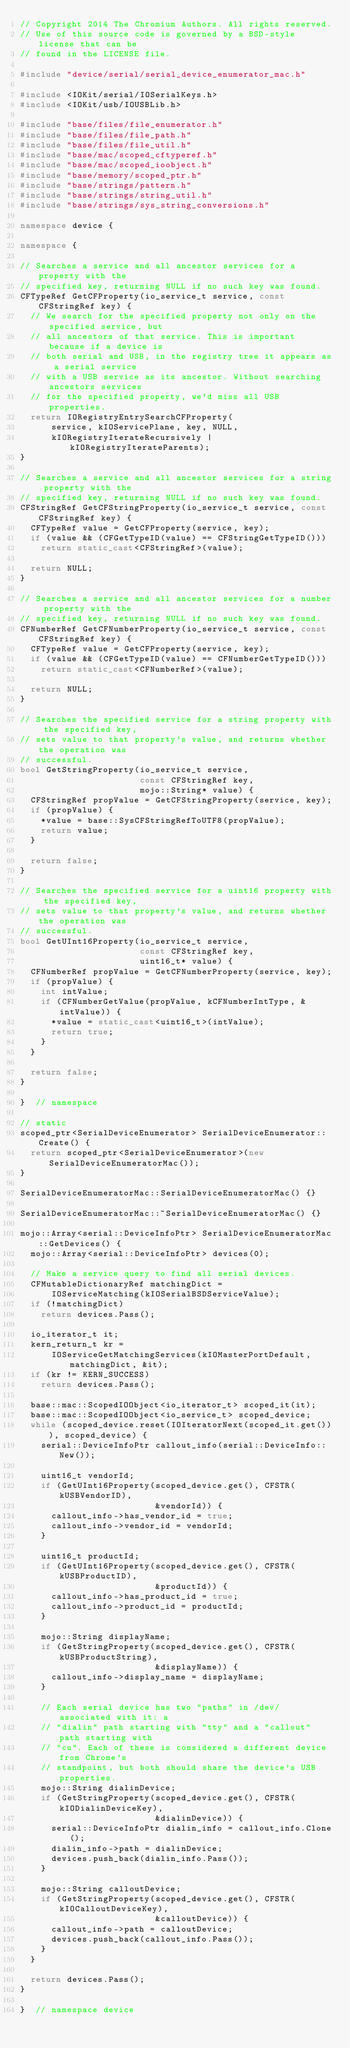<code> <loc_0><loc_0><loc_500><loc_500><_C++_>// Copyright 2014 The Chromium Authors. All rights reserved.
// Use of this source code is governed by a BSD-style license that can be
// found in the LICENSE file.

#include "device/serial/serial_device_enumerator_mac.h"

#include <IOKit/serial/IOSerialKeys.h>
#include <IOKit/usb/IOUSBLib.h>

#include "base/files/file_enumerator.h"
#include "base/files/file_path.h"
#include "base/files/file_util.h"
#include "base/mac/scoped_cftyperef.h"
#include "base/mac/scoped_ioobject.h"
#include "base/memory/scoped_ptr.h"
#include "base/strings/pattern.h"
#include "base/strings/string_util.h"
#include "base/strings/sys_string_conversions.h"

namespace device {

namespace {

// Searches a service and all ancestor services for a property with the
// specified key, returning NULL if no such key was found.
CFTypeRef GetCFProperty(io_service_t service, const CFStringRef key) {
  // We search for the specified property not only on the specified service, but
  // all ancestors of that service. This is important because if a device is
  // both serial and USB, in the registry tree it appears as a serial service
  // with a USB service as its ancestor. Without searching ancestors services
  // for the specified property, we'd miss all USB properties.
  return IORegistryEntrySearchCFProperty(
      service, kIOServicePlane, key, NULL,
      kIORegistryIterateRecursively | kIORegistryIterateParents);
}

// Searches a service and all ancestor services for a string property with the
// specified key, returning NULL if no such key was found.
CFStringRef GetCFStringProperty(io_service_t service, const CFStringRef key) {
  CFTypeRef value = GetCFProperty(service, key);
  if (value && (CFGetTypeID(value) == CFStringGetTypeID()))
    return static_cast<CFStringRef>(value);

  return NULL;
}

// Searches a service and all ancestor services for a number property with the
// specified key, returning NULL if no such key was found.
CFNumberRef GetCFNumberProperty(io_service_t service, const CFStringRef key) {
  CFTypeRef value = GetCFProperty(service, key);
  if (value && (CFGetTypeID(value) == CFNumberGetTypeID()))
    return static_cast<CFNumberRef>(value);

  return NULL;
}

// Searches the specified service for a string property with the specified key,
// sets value to that property's value, and returns whether the operation was
// successful.
bool GetStringProperty(io_service_t service,
                       const CFStringRef key,
                       mojo::String* value) {
  CFStringRef propValue = GetCFStringProperty(service, key);
  if (propValue) {
    *value = base::SysCFStringRefToUTF8(propValue);
    return value;
  }

  return false;
}

// Searches the specified service for a uint16 property with the specified key,
// sets value to that property's value, and returns whether the operation was
// successful.
bool GetUInt16Property(io_service_t service,
                       const CFStringRef key,
                       uint16_t* value) {
  CFNumberRef propValue = GetCFNumberProperty(service, key);
  if (propValue) {
    int intValue;
    if (CFNumberGetValue(propValue, kCFNumberIntType, &intValue)) {
      *value = static_cast<uint16_t>(intValue);
      return true;
    }
  }

  return false;
}

}  // namespace

// static
scoped_ptr<SerialDeviceEnumerator> SerialDeviceEnumerator::Create() {
  return scoped_ptr<SerialDeviceEnumerator>(new SerialDeviceEnumeratorMac());
}

SerialDeviceEnumeratorMac::SerialDeviceEnumeratorMac() {}

SerialDeviceEnumeratorMac::~SerialDeviceEnumeratorMac() {}

mojo::Array<serial::DeviceInfoPtr> SerialDeviceEnumeratorMac::GetDevices() {
  mojo::Array<serial::DeviceInfoPtr> devices(0);

  // Make a service query to find all serial devices.
  CFMutableDictionaryRef matchingDict =
      IOServiceMatching(kIOSerialBSDServiceValue);
  if (!matchingDict)
    return devices.Pass();

  io_iterator_t it;
  kern_return_t kr =
      IOServiceGetMatchingServices(kIOMasterPortDefault, matchingDict, &it);
  if (kr != KERN_SUCCESS)
    return devices.Pass();

  base::mac::ScopedIOObject<io_iterator_t> scoped_it(it);
  base::mac::ScopedIOObject<io_service_t> scoped_device;
  while (scoped_device.reset(IOIteratorNext(scoped_it.get())), scoped_device) {
    serial::DeviceInfoPtr callout_info(serial::DeviceInfo::New());

    uint16_t vendorId;
    if (GetUInt16Property(scoped_device.get(), CFSTR(kUSBVendorID),
                          &vendorId)) {
      callout_info->has_vendor_id = true;
      callout_info->vendor_id = vendorId;
    }

    uint16_t productId;
    if (GetUInt16Property(scoped_device.get(), CFSTR(kUSBProductID),
                          &productId)) {
      callout_info->has_product_id = true;
      callout_info->product_id = productId;
    }

    mojo::String displayName;
    if (GetStringProperty(scoped_device.get(), CFSTR(kUSBProductString),
                          &displayName)) {
      callout_info->display_name = displayName;
    }

    // Each serial device has two "paths" in /dev/ associated with it: a
    // "dialin" path starting with "tty" and a "callout" path starting with
    // "cu". Each of these is considered a different device from Chrome's
    // standpoint, but both should share the device's USB properties.
    mojo::String dialinDevice;
    if (GetStringProperty(scoped_device.get(), CFSTR(kIODialinDeviceKey),
                          &dialinDevice)) {
      serial::DeviceInfoPtr dialin_info = callout_info.Clone();
      dialin_info->path = dialinDevice;
      devices.push_back(dialin_info.Pass());
    }

    mojo::String calloutDevice;
    if (GetStringProperty(scoped_device.get(), CFSTR(kIOCalloutDeviceKey),
                          &calloutDevice)) {
      callout_info->path = calloutDevice;
      devices.push_back(callout_info.Pass());
    }
  }

  return devices.Pass();
}

}  // namespace device
</code> 